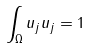<formula> <loc_0><loc_0><loc_500><loc_500>\int _ { \Omega } u _ { j } u _ { j } = 1</formula> 